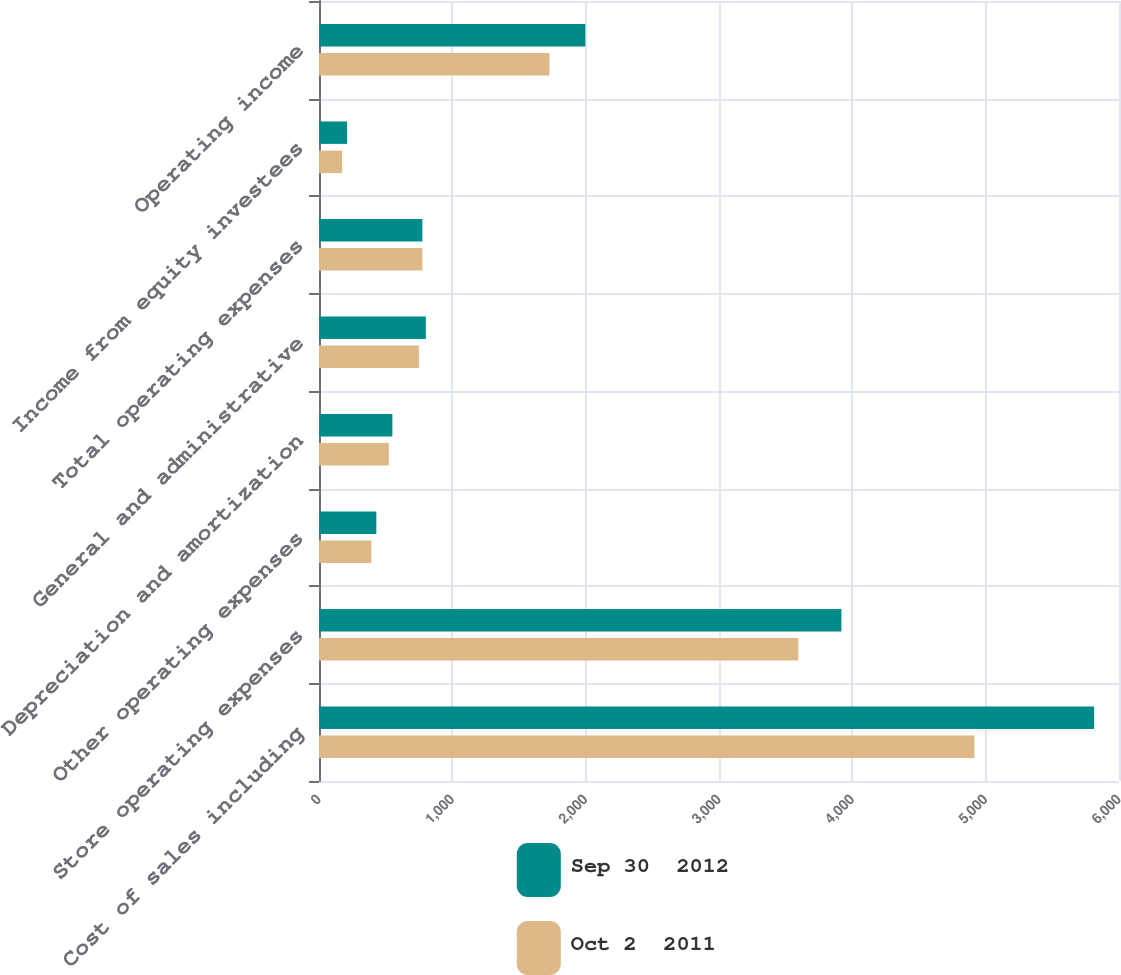<chart> <loc_0><loc_0><loc_500><loc_500><stacked_bar_chart><ecel><fcel>Cost of sales including<fcel>Store operating expenses<fcel>Other operating expenses<fcel>Depreciation and amortization<fcel>General and administrative<fcel>Total operating expenses<fcel>Income from equity investees<fcel>Operating income<nl><fcel>Sep 30  2012<fcel>5813.3<fcel>3918.1<fcel>429.9<fcel>550.3<fcel>801.2<fcel>775.25<fcel>210.7<fcel>1997.4<nl><fcel>Oct 2  2011<fcel>4915.5<fcel>3594.9<fcel>392.8<fcel>523.3<fcel>749.3<fcel>775.25<fcel>173.7<fcel>1728.5<nl></chart> 